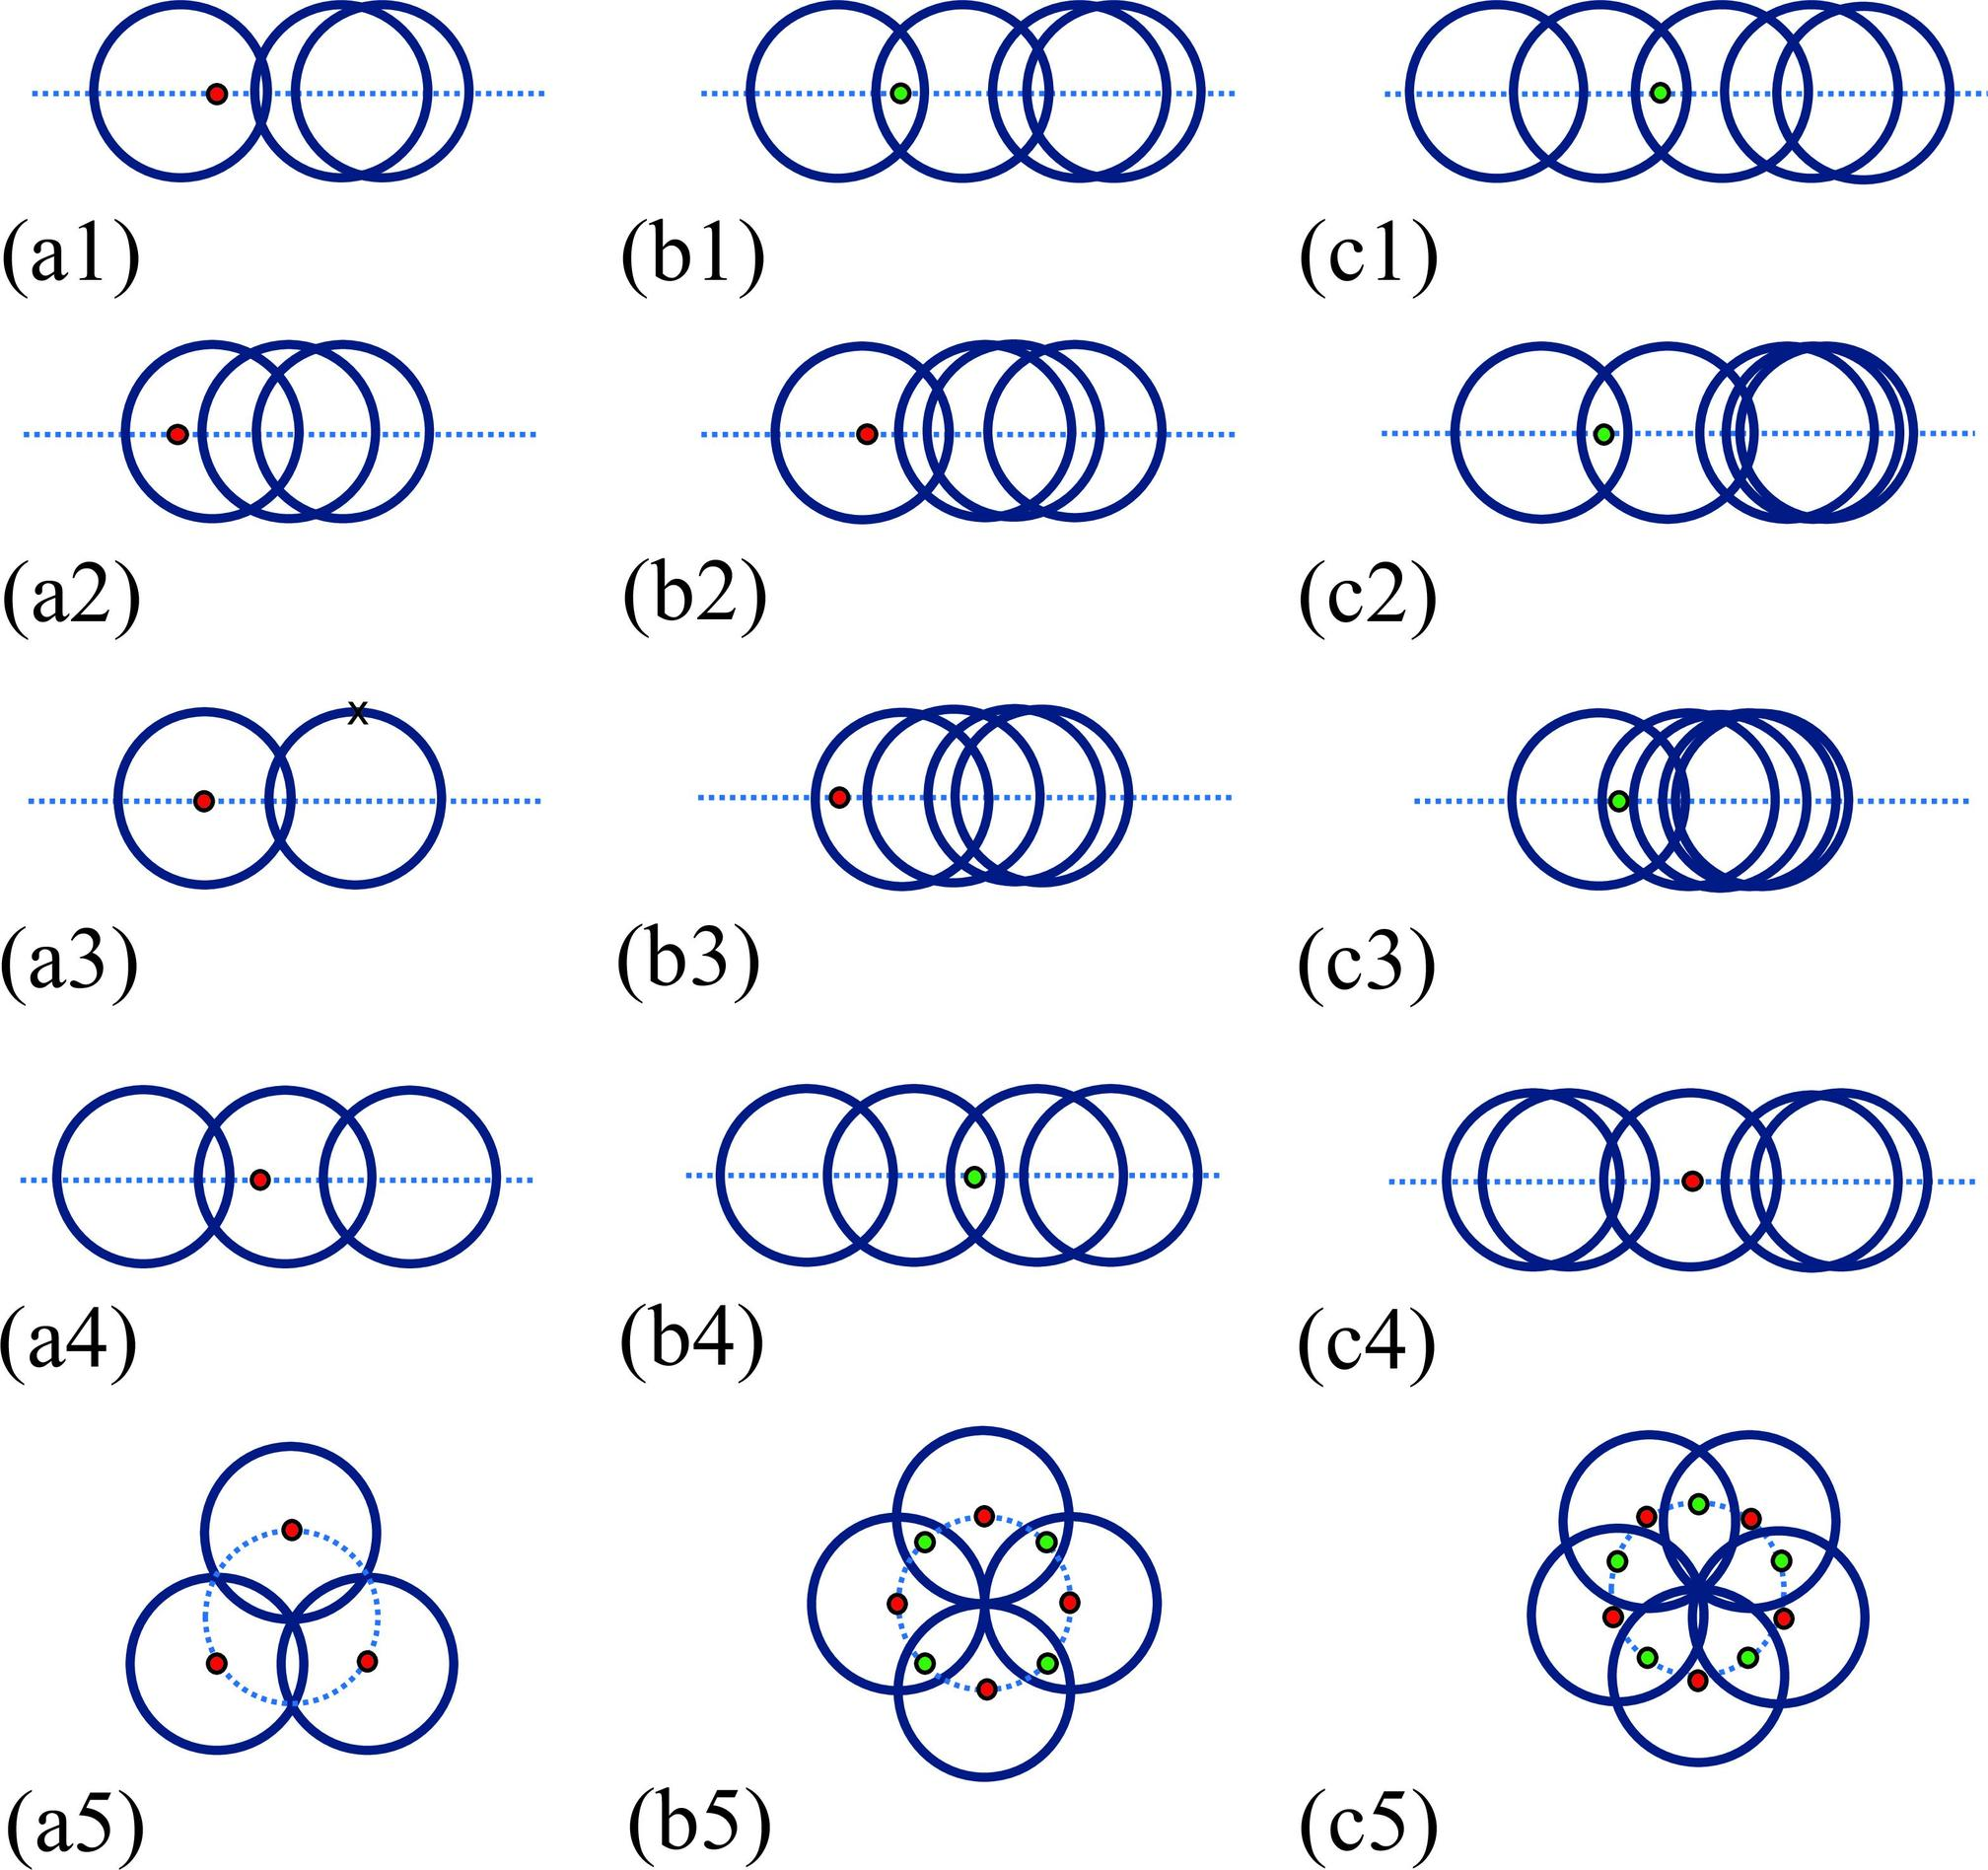Based on the sequence in figures a1 to a5, can you describe how the mechanism of the blue circles evolves over the series? In figures a1 to a5, the evolution of the blue circles appears to show progressive complexity in their pattern and collaboration. Initially, they are positioned simply around a central dot, but as the sequence progresses, we see the circles overlap more intricately and form more complex junctions. This suggests a development in the mechanism from basic encapsulation in a1 to a coordinated, overlay network by a5, possibly implying a sophisticated function or process. 